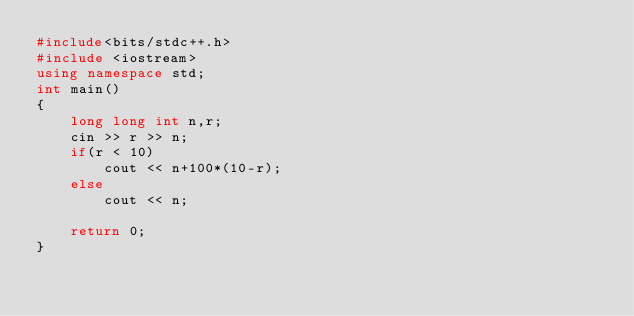Convert code to text. <code><loc_0><loc_0><loc_500><loc_500><_C++_>#include<bits/stdc++.h>
#include <iostream>
using namespace std;
int main()
{
    long long int n,r;
    cin >> r >> n;
    if(r < 10)
        cout << n+100*(10-r);
    else
        cout << n; 

    return 0;
}
</code> 